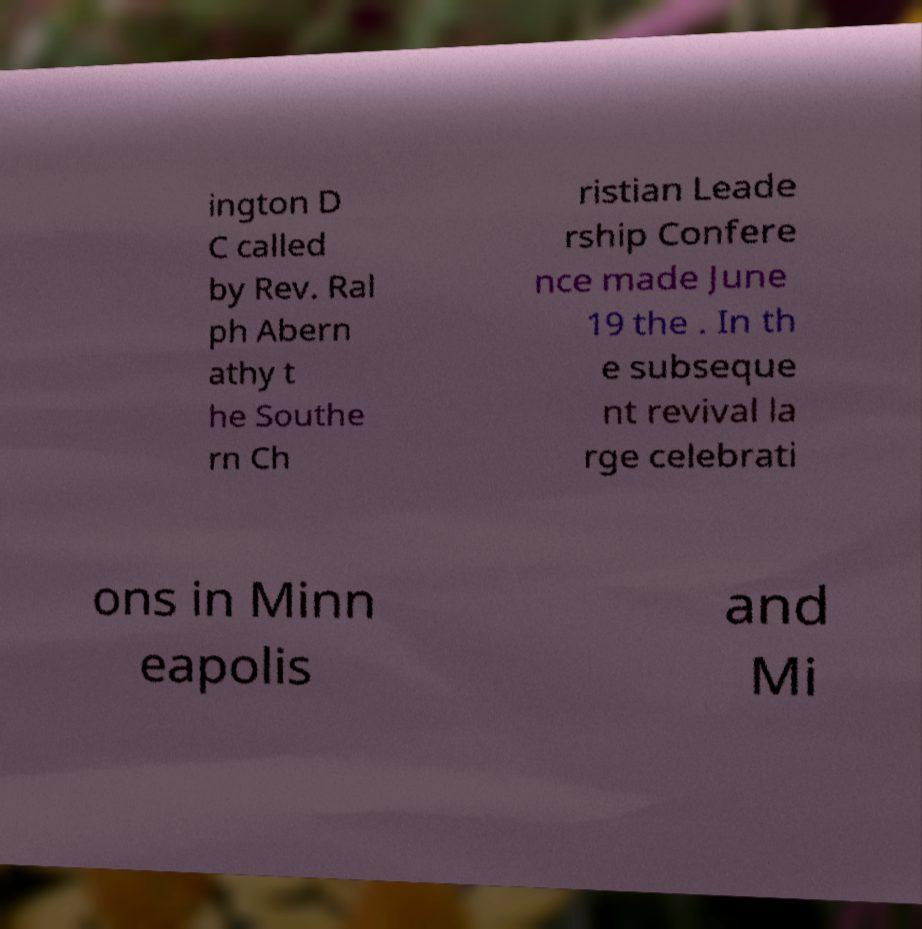Can you read and provide the text displayed in the image?This photo seems to have some interesting text. Can you extract and type it out for me? ington D C called by Rev. Ral ph Abern athy t he Southe rn Ch ristian Leade rship Confere nce made June 19 the . In th e subseque nt revival la rge celebrati ons in Minn eapolis and Mi 